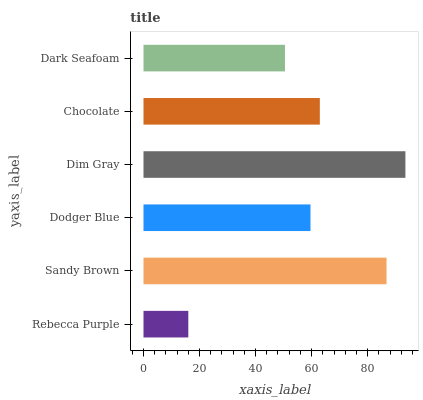Is Rebecca Purple the minimum?
Answer yes or no. Yes. Is Dim Gray the maximum?
Answer yes or no. Yes. Is Sandy Brown the minimum?
Answer yes or no. No. Is Sandy Brown the maximum?
Answer yes or no. No. Is Sandy Brown greater than Rebecca Purple?
Answer yes or no. Yes. Is Rebecca Purple less than Sandy Brown?
Answer yes or no. Yes. Is Rebecca Purple greater than Sandy Brown?
Answer yes or no. No. Is Sandy Brown less than Rebecca Purple?
Answer yes or no. No. Is Chocolate the high median?
Answer yes or no. Yes. Is Dodger Blue the low median?
Answer yes or no. Yes. Is Rebecca Purple the high median?
Answer yes or no. No. Is Rebecca Purple the low median?
Answer yes or no. No. 